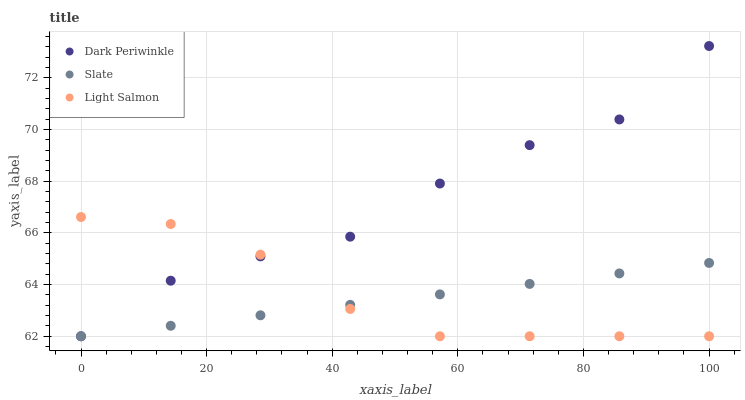Does Slate have the minimum area under the curve?
Answer yes or no. Yes. Does Dark Periwinkle have the maximum area under the curve?
Answer yes or no. Yes. Does Light Salmon have the minimum area under the curve?
Answer yes or no. No. Does Light Salmon have the maximum area under the curve?
Answer yes or no. No. Is Slate the smoothest?
Answer yes or no. Yes. Is Dark Periwinkle the roughest?
Answer yes or no. Yes. Is Light Salmon the smoothest?
Answer yes or no. No. Is Light Salmon the roughest?
Answer yes or no. No. Does Slate have the lowest value?
Answer yes or no. Yes. Does Dark Periwinkle have the highest value?
Answer yes or no. Yes. Does Light Salmon have the highest value?
Answer yes or no. No. Does Light Salmon intersect Dark Periwinkle?
Answer yes or no. Yes. Is Light Salmon less than Dark Periwinkle?
Answer yes or no. No. Is Light Salmon greater than Dark Periwinkle?
Answer yes or no. No. 